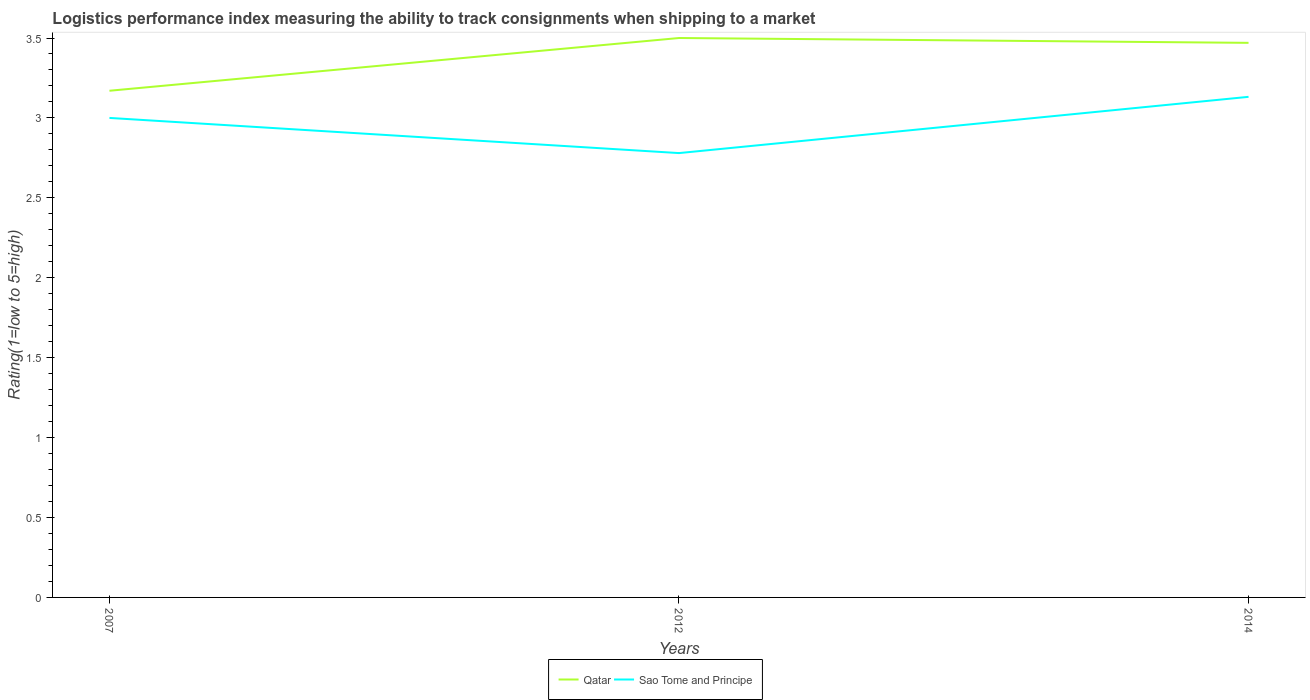How many different coloured lines are there?
Your answer should be very brief. 2. Across all years, what is the maximum Logistic performance index in Sao Tome and Principe?
Your response must be concise. 2.78. In which year was the Logistic performance index in Sao Tome and Principe maximum?
Your answer should be compact. 2012. What is the total Logistic performance index in Sao Tome and Principe in the graph?
Your response must be concise. 0.22. What is the difference between the highest and the second highest Logistic performance index in Sao Tome and Principe?
Your answer should be very brief. 0.35. Is the Logistic performance index in Sao Tome and Principe strictly greater than the Logistic performance index in Qatar over the years?
Keep it short and to the point. Yes. Are the values on the major ticks of Y-axis written in scientific E-notation?
Keep it short and to the point. No. Where does the legend appear in the graph?
Keep it short and to the point. Bottom center. How many legend labels are there?
Your response must be concise. 2. How are the legend labels stacked?
Offer a terse response. Horizontal. What is the title of the graph?
Your answer should be very brief. Logistics performance index measuring the ability to track consignments when shipping to a market. Does "Uganda" appear as one of the legend labels in the graph?
Your response must be concise. No. What is the label or title of the Y-axis?
Offer a terse response. Rating(1=low to 5=high). What is the Rating(1=low to 5=high) in Qatar in 2007?
Provide a succinct answer. 3.17. What is the Rating(1=low to 5=high) of Sao Tome and Principe in 2012?
Keep it short and to the point. 2.78. What is the Rating(1=low to 5=high) in Qatar in 2014?
Ensure brevity in your answer.  3.47. What is the Rating(1=low to 5=high) of Sao Tome and Principe in 2014?
Provide a short and direct response. 3.13. Across all years, what is the maximum Rating(1=low to 5=high) of Sao Tome and Principe?
Make the answer very short. 3.13. Across all years, what is the minimum Rating(1=low to 5=high) in Qatar?
Keep it short and to the point. 3.17. Across all years, what is the minimum Rating(1=low to 5=high) of Sao Tome and Principe?
Your answer should be very brief. 2.78. What is the total Rating(1=low to 5=high) of Qatar in the graph?
Provide a succinct answer. 10.14. What is the total Rating(1=low to 5=high) of Sao Tome and Principe in the graph?
Keep it short and to the point. 8.91. What is the difference between the Rating(1=low to 5=high) in Qatar in 2007 and that in 2012?
Keep it short and to the point. -0.33. What is the difference between the Rating(1=low to 5=high) of Sao Tome and Principe in 2007 and that in 2012?
Provide a succinct answer. 0.22. What is the difference between the Rating(1=low to 5=high) of Qatar in 2007 and that in 2014?
Offer a very short reply. -0.3. What is the difference between the Rating(1=low to 5=high) of Sao Tome and Principe in 2007 and that in 2014?
Offer a very short reply. -0.13. What is the difference between the Rating(1=low to 5=high) in Qatar in 2012 and that in 2014?
Make the answer very short. 0.03. What is the difference between the Rating(1=low to 5=high) in Sao Tome and Principe in 2012 and that in 2014?
Keep it short and to the point. -0.35. What is the difference between the Rating(1=low to 5=high) in Qatar in 2007 and the Rating(1=low to 5=high) in Sao Tome and Principe in 2012?
Your answer should be very brief. 0.39. What is the difference between the Rating(1=low to 5=high) in Qatar in 2007 and the Rating(1=low to 5=high) in Sao Tome and Principe in 2014?
Give a very brief answer. 0.04. What is the difference between the Rating(1=low to 5=high) of Qatar in 2012 and the Rating(1=low to 5=high) of Sao Tome and Principe in 2014?
Your response must be concise. 0.37. What is the average Rating(1=low to 5=high) of Qatar per year?
Keep it short and to the point. 3.38. What is the average Rating(1=low to 5=high) of Sao Tome and Principe per year?
Offer a terse response. 2.97. In the year 2007, what is the difference between the Rating(1=low to 5=high) of Qatar and Rating(1=low to 5=high) of Sao Tome and Principe?
Ensure brevity in your answer.  0.17. In the year 2012, what is the difference between the Rating(1=low to 5=high) in Qatar and Rating(1=low to 5=high) in Sao Tome and Principe?
Your response must be concise. 0.72. In the year 2014, what is the difference between the Rating(1=low to 5=high) in Qatar and Rating(1=low to 5=high) in Sao Tome and Principe?
Your response must be concise. 0.34. What is the ratio of the Rating(1=low to 5=high) in Qatar in 2007 to that in 2012?
Ensure brevity in your answer.  0.91. What is the ratio of the Rating(1=low to 5=high) in Sao Tome and Principe in 2007 to that in 2012?
Give a very brief answer. 1.08. What is the ratio of the Rating(1=low to 5=high) in Qatar in 2007 to that in 2014?
Provide a succinct answer. 0.91. What is the ratio of the Rating(1=low to 5=high) of Sao Tome and Principe in 2007 to that in 2014?
Your response must be concise. 0.96. What is the ratio of the Rating(1=low to 5=high) in Qatar in 2012 to that in 2014?
Your answer should be very brief. 1.01. What is the ratio of the Rating(1=low to 5=high) of Sao Tome and Principe in 2012 to that in 2014?
Offer a terse response. 0.89. What is the difference between the highest and the second highest Rating(1=low to 5=high) of Qatar?
Offer a terse response. 0.03. What is the difference between the highest and the second highest Rating(1=low to 5=high) in Sao Tome and Principe?
Provide a succinct answer. 0.13. What is the difference between the highest and the lowest Rating(1=low to 5=high) of Qatar?
Ensure brevity in your answer.  0.33. What is the difference between the highest and the lowest Rating(1=low to 5=high) of Sao Tome and Principe?
Offer a very short reply. 0.35. 